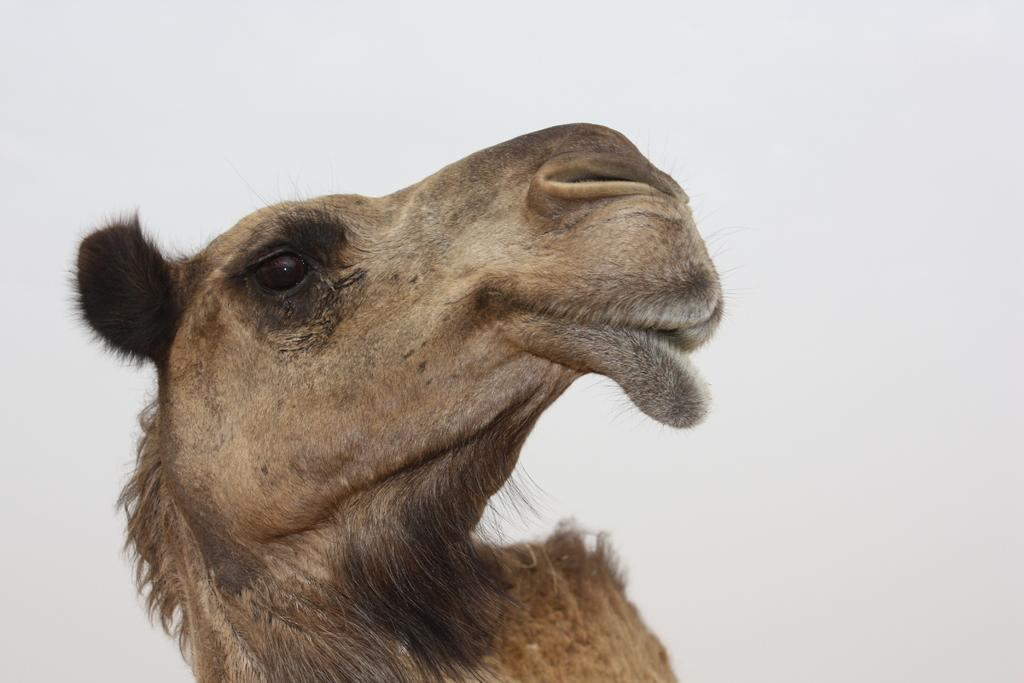What animal is present in the image? There is a camel in the image. What part of the natural environment is visible in the image? The sky is visible in the image. What type of powder can be seen falling from the sky in the image? There is no powder falling from the sky in the image; only the camel and sky are present. What does the goat smell like in the image? There is no goat present in the image, so it is not possible to determine what it might smell like. 